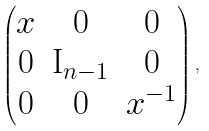<formula> <loc_0><loc_0><loc_500><loc_500>\begin{pmatrix} x & 0 & 0 \\ 0 & \mathrm I _ { n - 1 } & 0 \\ 0 & 0 & x ^ { - 1 } \end{pmatrix} ,</formula> 